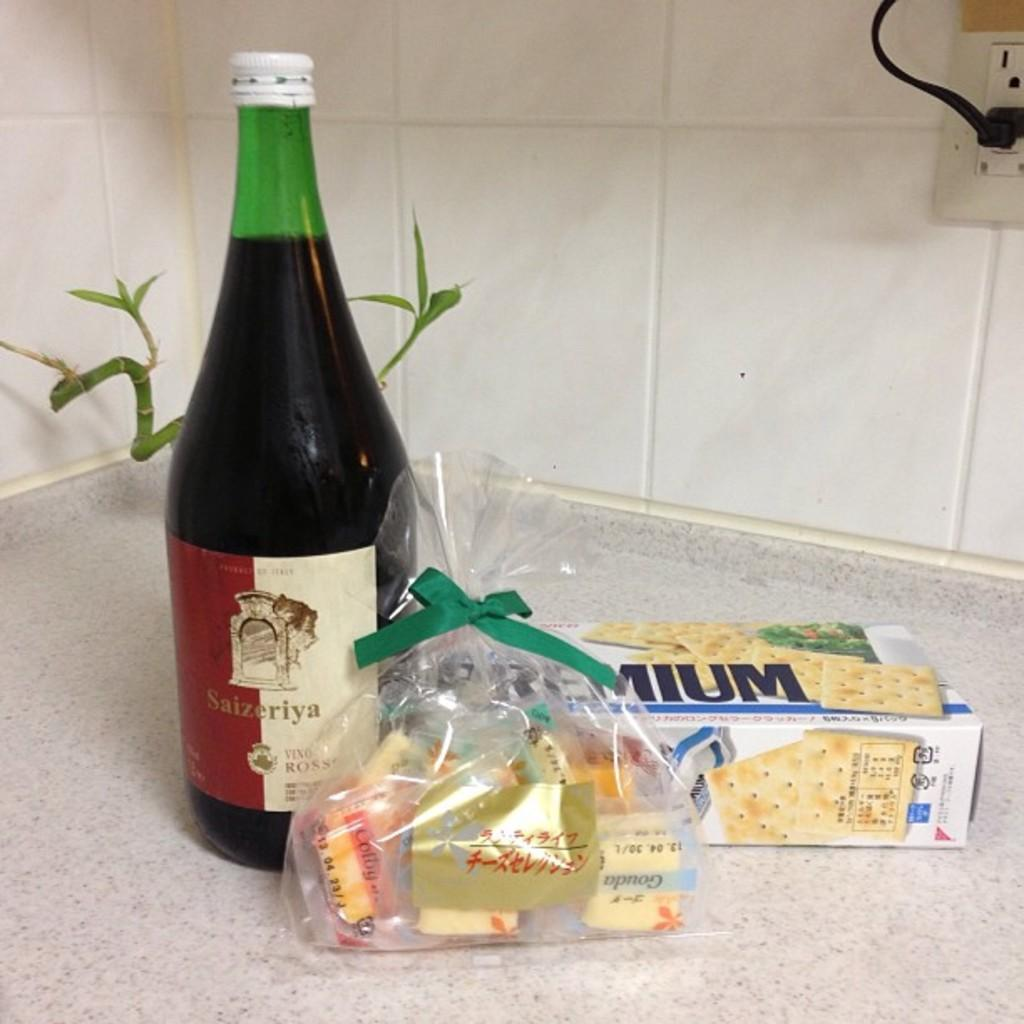Provide a one-sentence caption for the provided image. A bottle of Saizeriya wine is on the counter next to premium brand crackers. 